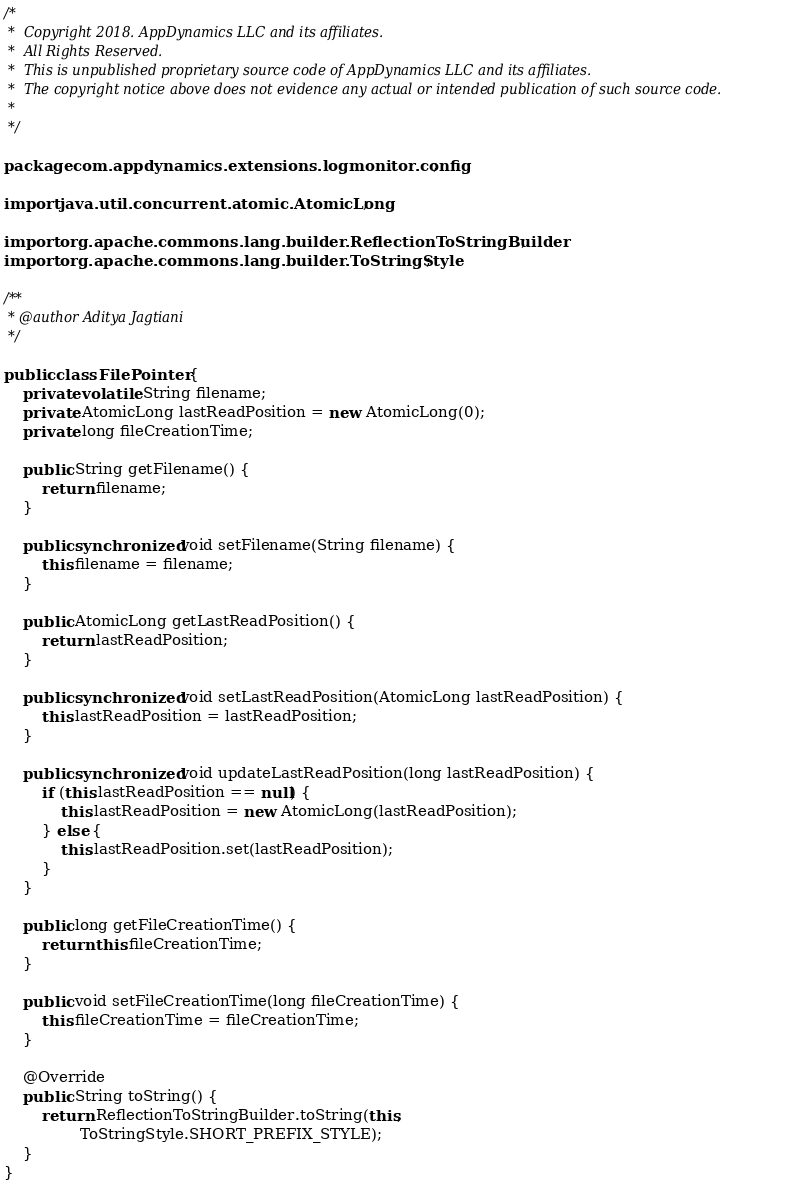Convert code to text. <code><loc_0><loc_0><loc_500><loc_500><_Java_>/*
 *  Copyright 2018. AppDynamics LLC and its affiliates.
 *  All Rights Reserved.
 *  This is unpublished proprietary source code of AppDynamics LLC and its affiliates.
 *  The copyright notice above does not evidence any actual or intended publication of such source code.
 *
 */

package com.appdynamics.extensions.logmonitor.config;

import java.util.concurrent.atomic.AtomicLong;

import org.apache.commons.lang.builder.ReflectionToStringBuilder;
import org.apache.commons.lang.builder.ToStringStyle;

/**
 * @author Aditya Jagtiani
 */

public class FilePointer {
    private volatile String filename;
    private AtomicLong lastReadPosition = new AtomicLong(0);
    private long fileCreationTime;

    public String getFilename() {
        return filename;
    }

    public synchronized void setFilename(String filename) {
        this.filename = filename;
    }

    public AtomicLong getLastReadPosition() {
        return lastReadPosition;
    }

    public synchronized void setLastReadPosition(AtomicLong lastReadPosition) {
        this.lastReadPosition = lastReadPosition;
    }

    public synchronized void updateLastReadPosition(long lastReadPosition) {
        if (this.lastReadPosition == null) {
            this.lastReadPosition = new AtomicLong(lastReadPosition);
        } else {
            this.lastReadPosition.set(lastReadPosition);
        }
    }

    public long getFileCreationTime() {
        return this.fileCreationTime;
    }

    public void setFileCreationTime(long fileCreationTime) {
        this.fileCreationTime = fileCreationTime;
    }

    @Override
    public String toString() {
        return ReflectionToStringBuilder.toString(this,
                ToStringStyle.SHORT_PREFIX_STYLE);
    }
}</code> 